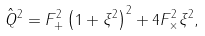<formula> <loc_0><loc_0><loc_500><loc_500>\hat { Q } ^ { 2 } = F _ { + } ^ { 2 } \left ( 1 + \xi ^ { 2 } \right ) ^ { 2 } + 4 F _ { \times } ^ { 2 } \xi ^ { 2 } ,</formula> 